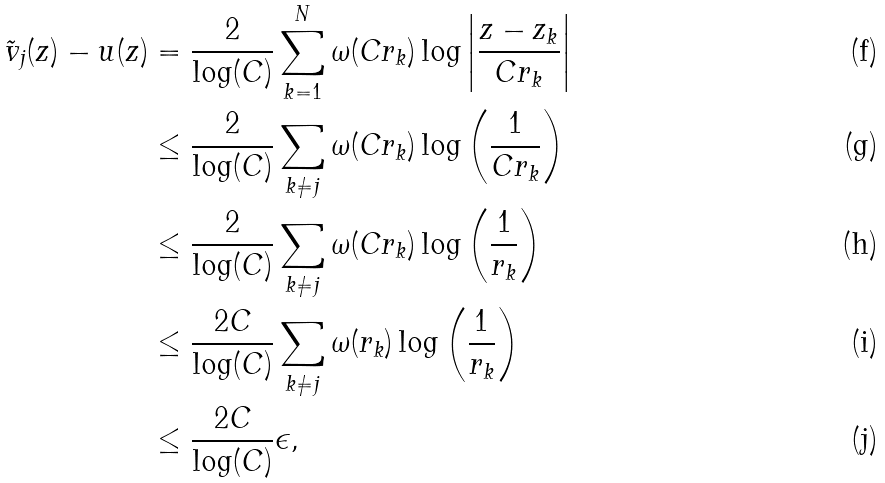<formula> <loc_0><loc_0><loc_500><loc_500>\tilde { v } _ { j } ( z ) - u ( z ) & = \frac { 2 } { \log ( C ) } \sum _ { k = 1 } ^ { N } \omega ( C r _ { k } ) \log \left | \frac { z - z _ { k } } { C r _ { k } } \right | \\ & \leq \frac { 2 } { \log ( C ) } \sum _ { k \neq j } \omega ( C r _ { k } ) \log \left ( \frac { 1 } { C r _ { k } } \right ) \\ & \leq \frac { 2 } { \log ( C ) } \sum _ { k \neq j } \omega ( C r _ { k } ) \log \left ( \frac { 1 } { r _ { k } } \right ) \\ & \leq \frac { 2 C } { \log ( C ) } \sum _ { k \neq j } \omega ( r _ { k } ) \log \left ( \frac { 1 } { r _ { k } } \right ) \\ & \leq \frac { 2 C } { \log ( C ) } \epsilon ,</formula> 